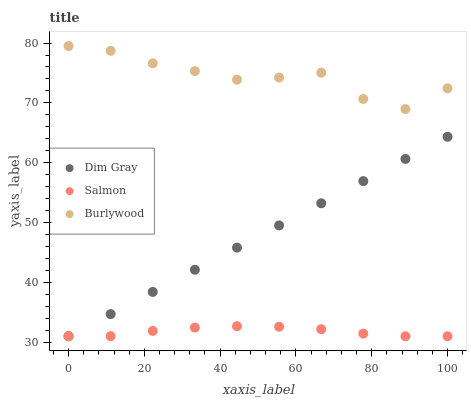Does Salmon have the minimum area under the curve?
Answer yes or no. Yes. Does Burlywood have the maximum area under the curve?
Answer yes or no. Yes. Does Dim Gray have the minimum area under the curve?
Answer yes or no. No. Does Dim Gray have the maximum area under the curve?
Answer yes or no. No. Is Dim Gray the smoothest?
Answer yes or no. Yes. Is Burlywood the roughest?
Answer yes or no. Yes. Is Salmon the smoothest?
Answer yes or no. No. Is Salmon the roughest?
Answer yes or no. No. Does Dim Gray have the lowest value?
Answer yes or no. Yes. Does Burlywood have the highest value?
Answer yes or no. Yes. Does Dim Gray have the highest value?
Answer yes or no. No. Is Salmon less than Burlywood?
Answer yes or no. Yes. Is Burlywood greater than Salmon?
Answer yes or no. Yes. Does Salmon intersect Dim Gray?
Answer yes or no. Yes. Is Salmon less than Dim Gray?
Answer yes or no. No. Is Salmon greater than Dim Gray?
Answer yes or no. No. Does Salmon intersect Burlywood?
Answer yes or no. No. 